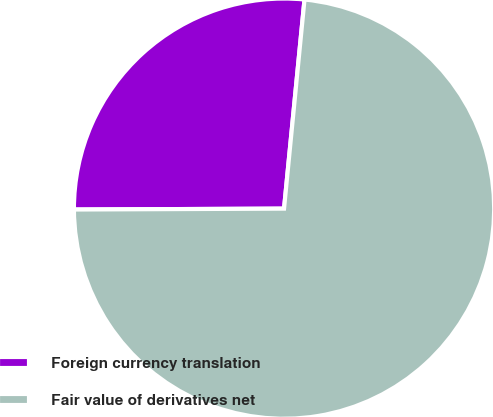Convert chart to OTSL. <chart><loc_0><loc_0><loc_500><loc_500><pie_chart><fcel>Foreign currency translation<fcel>Fair value of derivatives net<nl><fcel>26.62%<fcel>73.38%<nl></chart> 